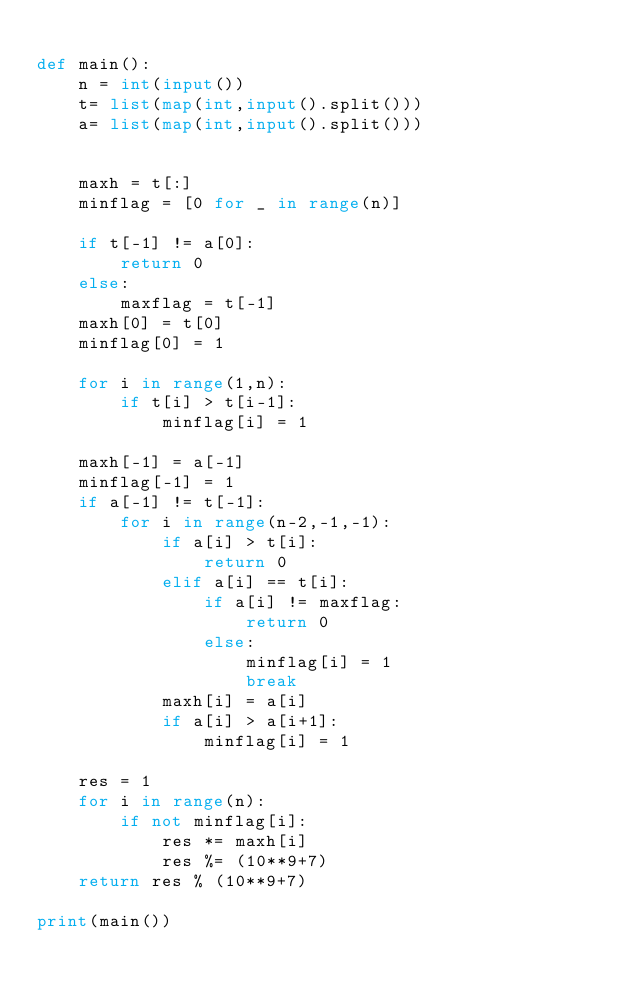Convert code to text. <code><loc_0><loc_0><loc_500><loc_500><_Python_>
def main():
    n = int(input())
    t= list(map(int,input().split()))
    a= list(map(int,input().split()))


    maxh = t[:]
    minflag = [0 for _ in range(n)]

    if t[-1] != a[0]:
        return 0
    else:
        maxflag = t[-1]
    maxh[0] = t[0]
    minflag[0] = 1

    for i in range(1,n):
        if t[i] > t[i-1]:
            minflag[i] = 1

    maxh[-1] = a[-1]
    minflag[-1] = 1
    if a[-1] != t[-1]:
        for i in range(n-2,-1,-1):
            if a[i] > t[i]:
                return 0
            elif a[i] == t[i]:
                if a[i] != maxflag:
                    return 0
                else:
                    minflag[i] = 1
                    break
            maxh[i] = a[i]
            if a[i] > a[i+1]:
                minflag[i] = 1

    res = 1
    for i in range(n):
        if not minflag[i]:
            res *= maxh[i]
            res %= (10**9+7)
    return res % (10**9+7)

print(main())</code> 